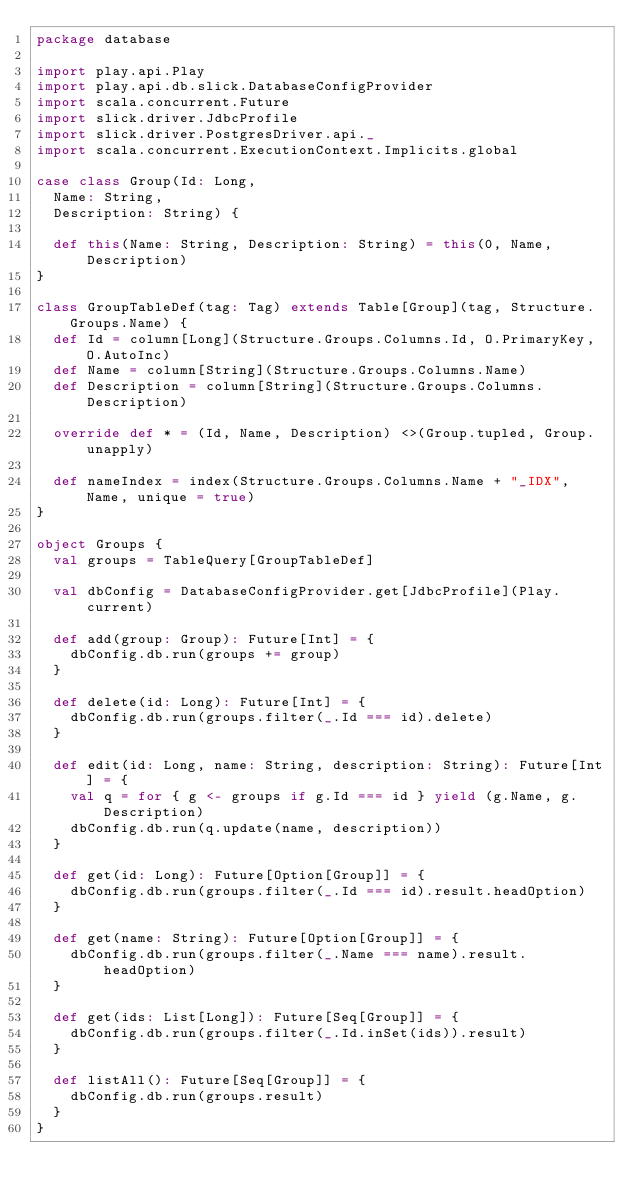Convert code to text. <code><loc_0><loc_0><loc_500><loc_500><_Scala_>package database

import play.api.Play
import play.api.db.slick.DatabaseConfigProvider
import scala.concurrent.Future
import slick.driver.JdbcProfile
import slick.driver.PostgresDriver.api._
import scala.concurrent.ExecutionContext.Implicits.global

case class Group(Id: Long,
  Name: String,
  Description: String) {

  def this(Name: String, Description: String) = this(0, Name, Description)
}

class GroupTableDef(tag: Tag) extends Table[Group](tag, Structure.Groups.Name) {
  def Id = column[Long](Structure.Groups.Columns.Id, O.PrimaryKey, O.AutoInc)
  def Name = column[String](Structure.Groups.Columns.Name)
  def Description = column[String](Structure.Groups.Columns.Description)

  override def * = (Id, Name, Description) <>(Group.tupled, Group.unapply)

  def nameIndex = index(Structure.Groups.Columns.Name + "_IDX", Name, unique = true)
}

object Groups {
  val groups = TableQuery[GroupTableDef]

  val dbConfig = DatabaseConfigProvider.get[JdbcProfile](Play.current)

  def add(group: Group): Future[Int] = {
    dbConfig.db.run(groups += group)
  }

  def delete(id: Long): Future[Int] = {
    dbConfig.db.run(groups.filter(_.Id === id).delete)
  }

  def edit(id: Long, name: String, description: String): Future[Int] = {
    val q = for { g <- groups if g.Id === id } yield (g.Name, g.Description)
    dbConfig.db.run(q.update(name, description))
  }

  def get(id: Long): Future[Option[Group]] = {
    dbConfig.db.run(groups.filter(_.Id === id).result.headOption)
  }

  def get(name: String): Future[Option[Group]] = {
    dbConfig.db.run(groups.filter(_.Name === name).result.headOption)
  }

  def get(ids: List[Long]): Future[Seq[Group]] = {
    dbConfig.db.run(groups.filter(_.Id.inSet(ids)).result)
  }

  def listAll(): Future[Seq[Group]] = {
    dbConfig.db.run(groups.result)
  }
}
</code> 